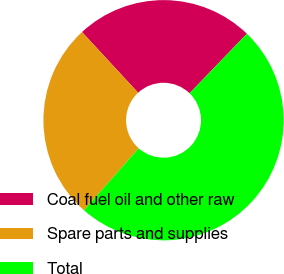Convert chart to OTSL. <chart><loc_0><loc_0><loc_500><loc_500><pie_chart><fcel>Coal fuel oil and other raw<fcel>Spare parts and supplies<fcel>Total<nl><fcel>24.08%<fcel>26.6%<fcel>49.32%<nl></chart> 